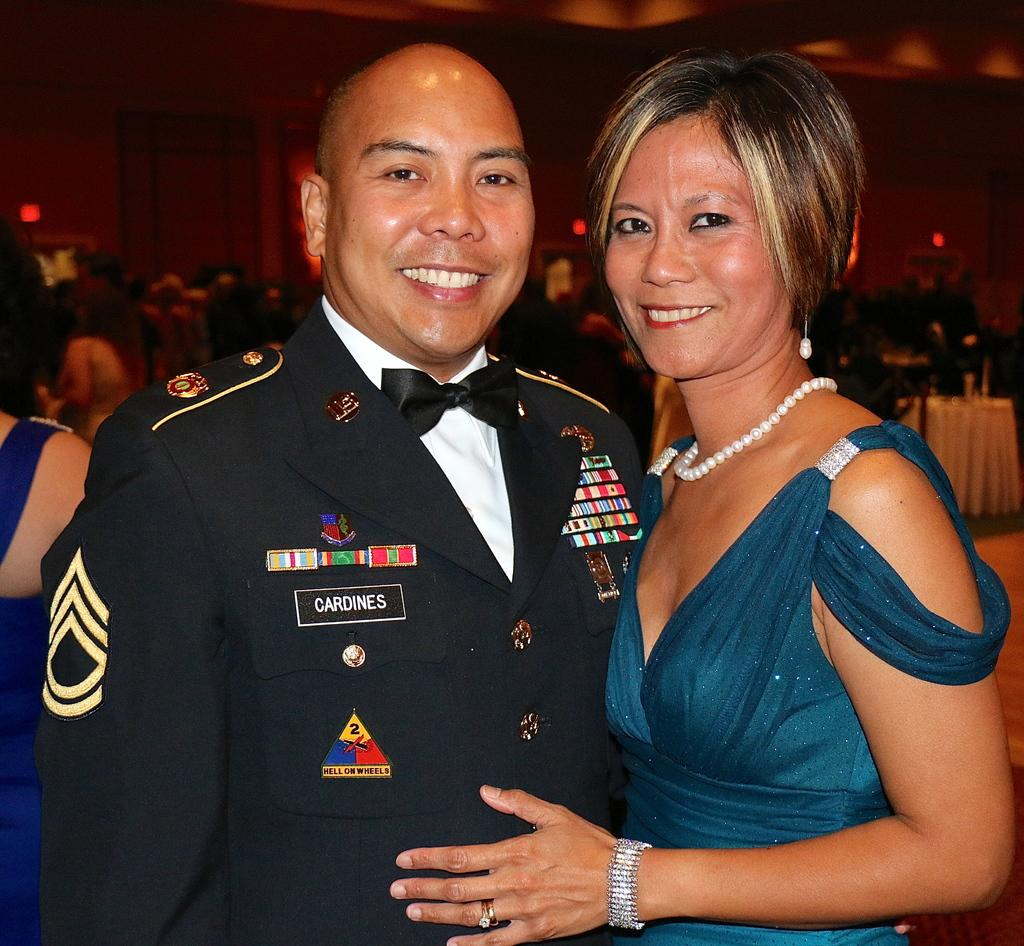Who can be seen in the foreground of the picture? There is a man and a woman in the foreground of the picture. What are they doing in the image? They are posing for a camera. What can be seen in the background of the image? There are tables, chairs, lights, a wall, and a ceiling in the background of the image. What type of book is the man holding in the image? There is no book present in the image; the man and woman are posing for a camera. 